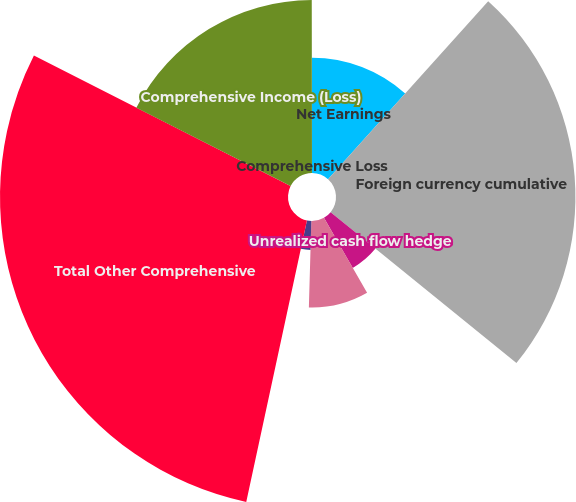Convert chart. <chart><loc_0><loc_0><loc_500><loc_500><pie_chart><fcel>Net Earnings<fcel>Foreign currency cumulative<fcel>Unrealized cash flow hedge<fcel>Reclassification adjustments<fcel>Adjustments to prior service<fcel>Total Other Comprehensive<fcel>Comprehensive Income (Loss)<fcel>Comprehensive Loss<nl><fcel>11.66%<fcel>24.2%<fcel>5.84%<fcel>8.75%<fcel>2.93%<fcel>29.11%<fcel>17.49%<fcel>0.02%<nl></chart> 